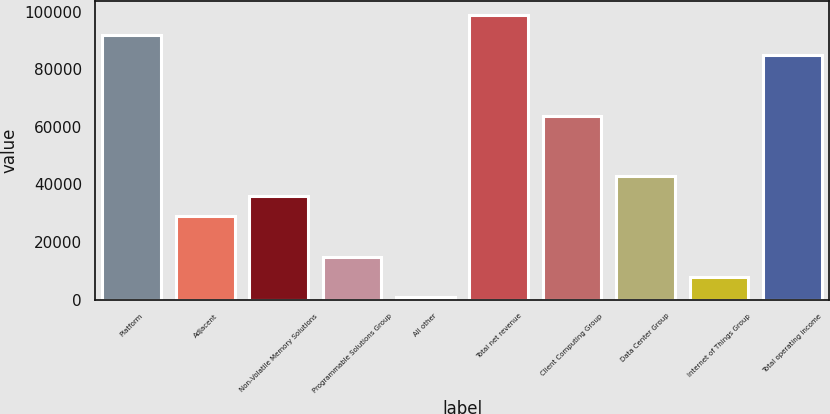<chart> <loc_0><loc_0><loc_500><loc_500><bar_chart><fcel>Platform<fcel>Adjacent<fcel>Non-Volatile Memory Solutions<fcel>Programmable Solutions Group<fcel>All other<fcel>Total net revenue<fcel>Client Computing Group<fcel>Data Center Group<fcel>Internet of Things Group<fcel>Total operating income<nl><fcel>91812<fcel>28920<fcel>35908<fcel>14944<fcel>968<fcel>98800<fcel>63860<fcel>42896<fcel>7956<fcel>84824<nl></chart> 